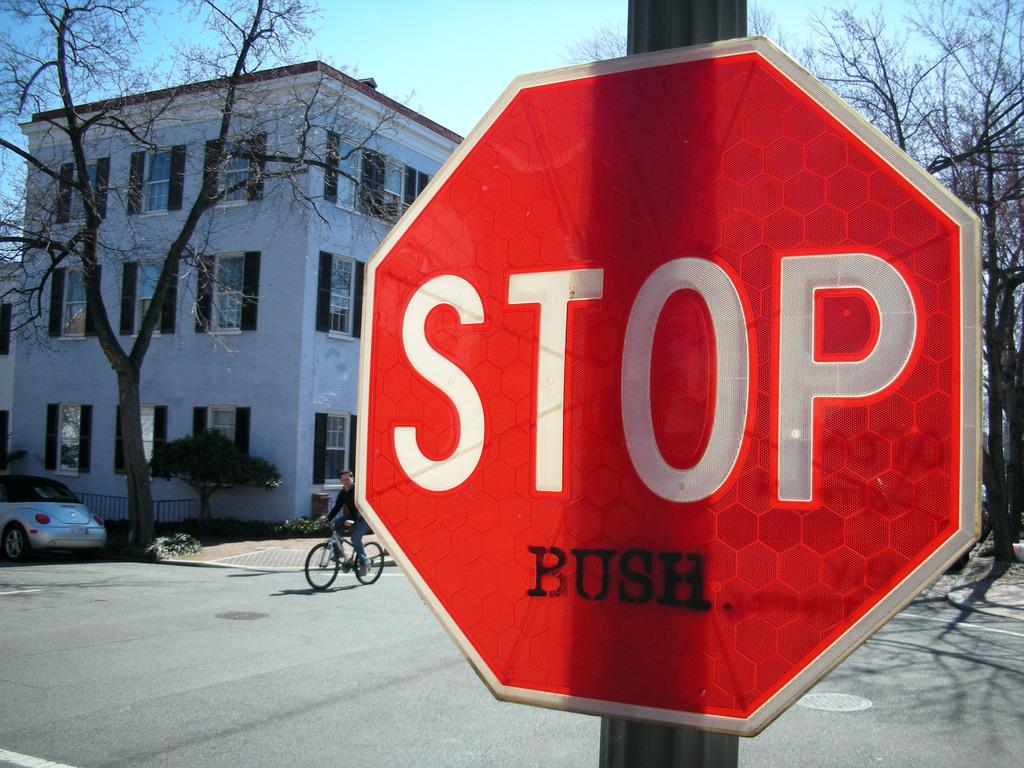Provide a one-sentence caption for the provided image. A red stop sign with Bush added below it stands in a street. 